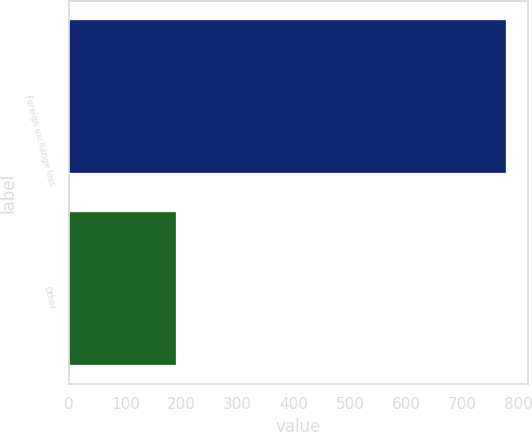<chart> <loc_0><loc_0><loc_500><loc_500><bar_chart><fcel>Foreign exchange loss<fcel>Other<nl><fcel>778<fcel>190<nl></chart> 